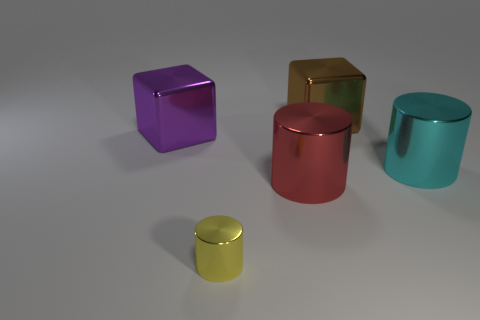Add 3 large red things. How many objects exist? 8 Subtract all cylinders. How many objects are left? 2 Add 5 big metallic blocks. How many big metallic blocks are left? 7 Add 5 yellow matte blocks. How many yellow matte blocks exist? 5 Subtract 0 cyan balls. How many objects are left? 5 Subtract all cyan cylinders. Subtract all purple spheres. How many objects are left? 4 